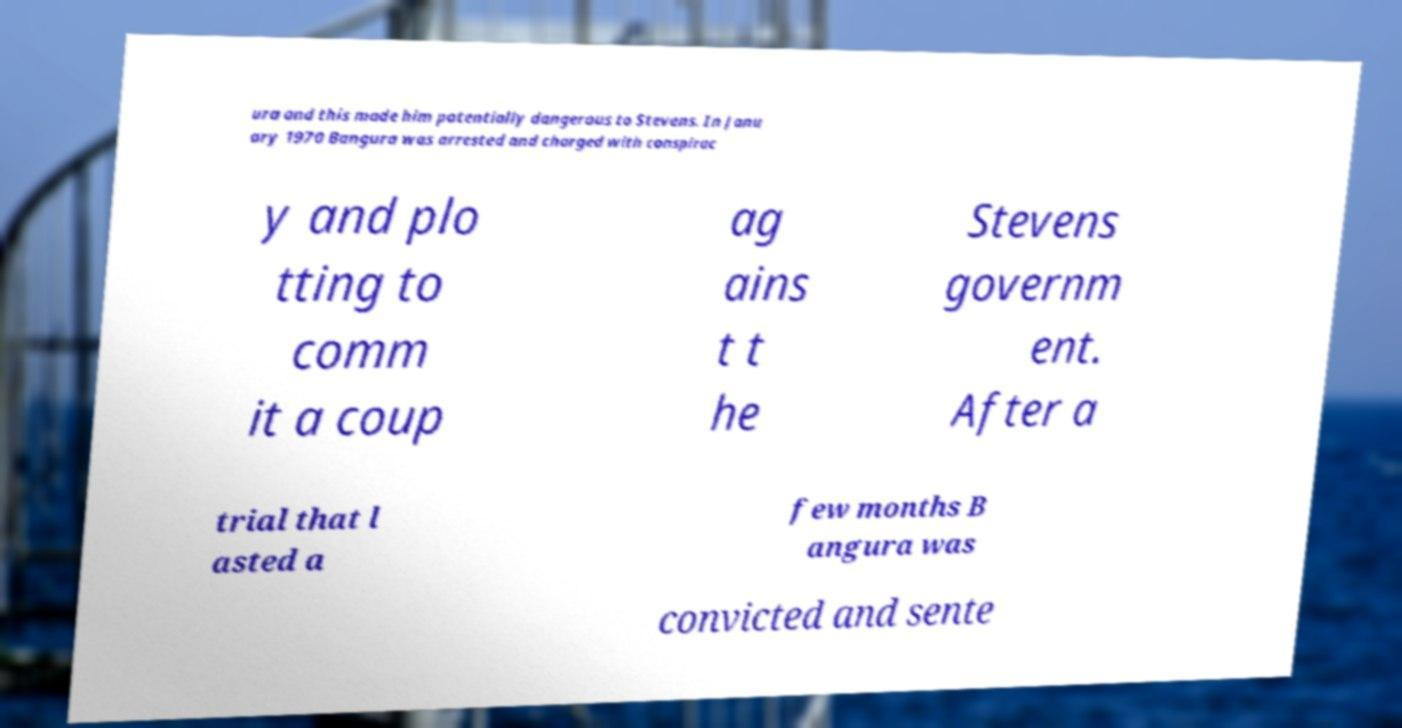Please read and relay the text visible in this image. What does it say? ura and this made him potentially dangerous to Stevens. In Janu ary 1970 Bangura was arrested and charged with conspirac y and plo tting to comm it a coup ag ains t t he Stevens governm ent. After a trial that l asted a few months B angura was convicted and sente 